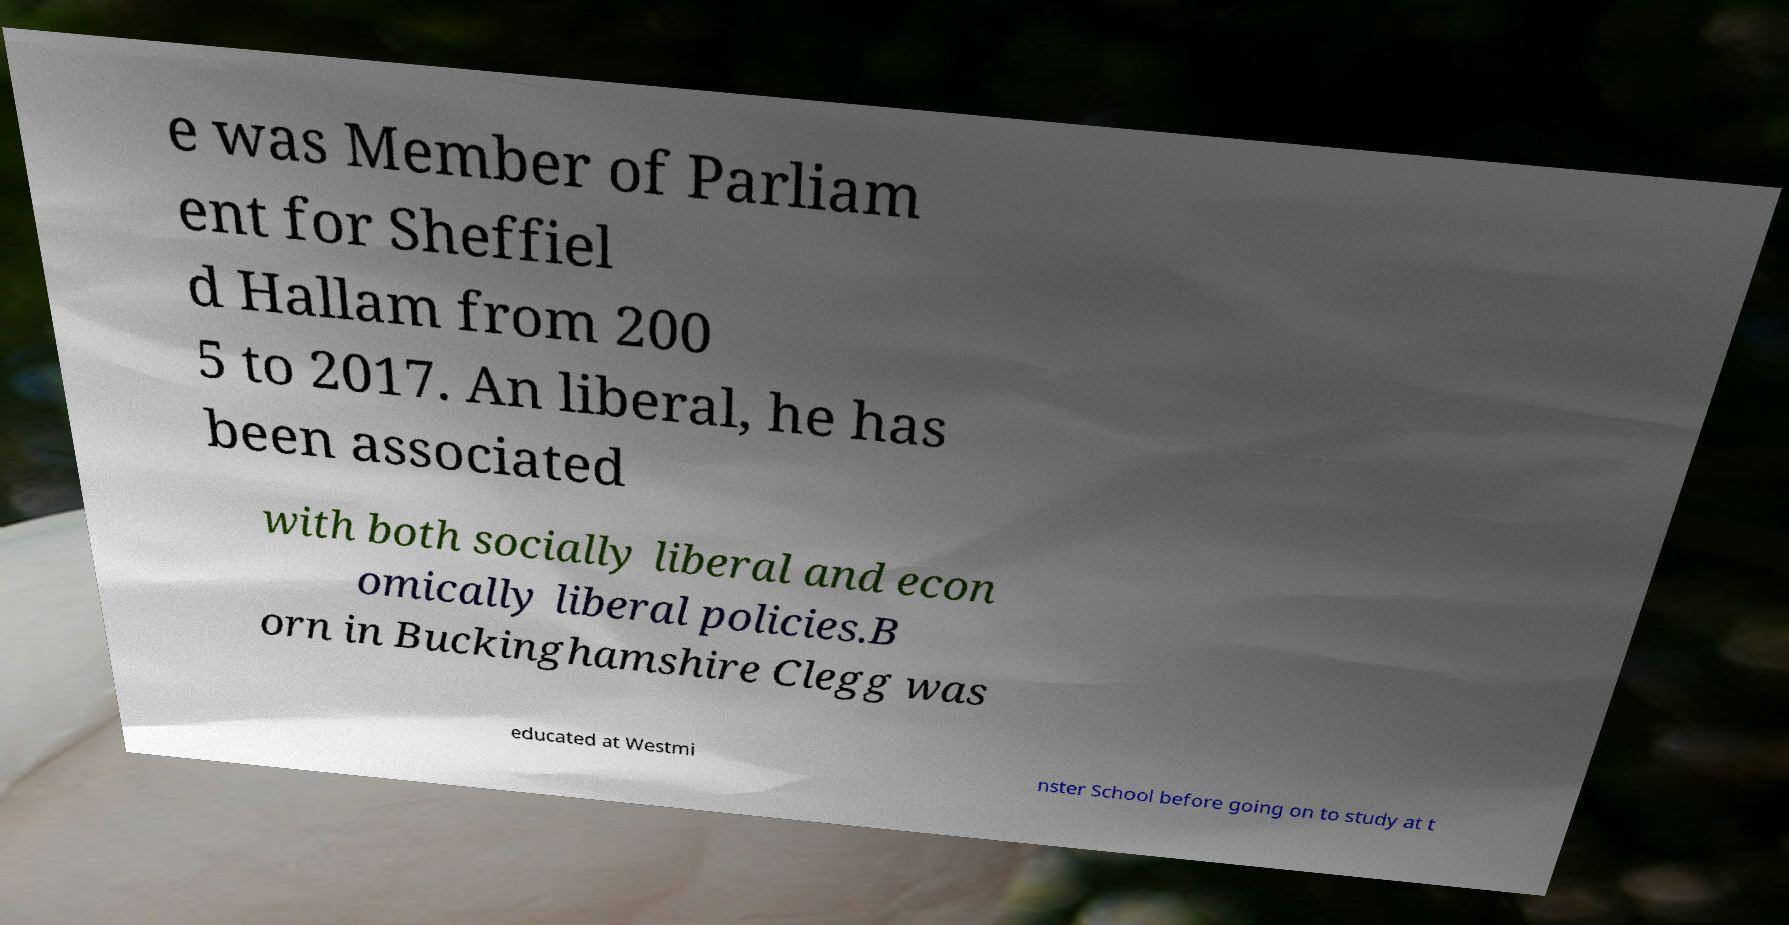Please read and relay the text visible in this image. What does it say? e was Member of Parliam ent for Sheffiel d Hallam from 200 5 to 2017. An liberal, he has been associated with both socially liberal and econ omically liberal policies.B orn in Buckinghamshire Clegg was educated at Westmi nster School before going on to study at t 